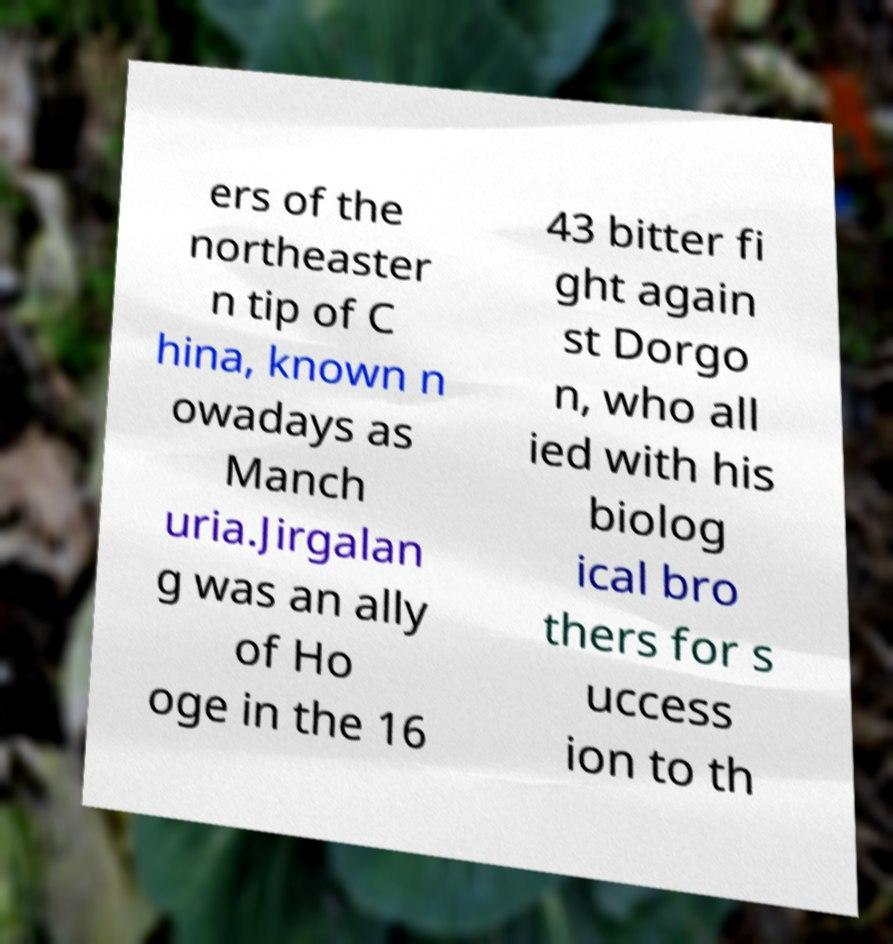Can you accurately transcribe the text from the provided image for me? ers of the northeaster n tip of C hina, known n owadays as Manch uria.Jirgalan g was an ally of Ho oge in the 16 43 bitter fi ght again st Dorgo n, who all ied with his biolog ical bro thers for s uccess ion to th 